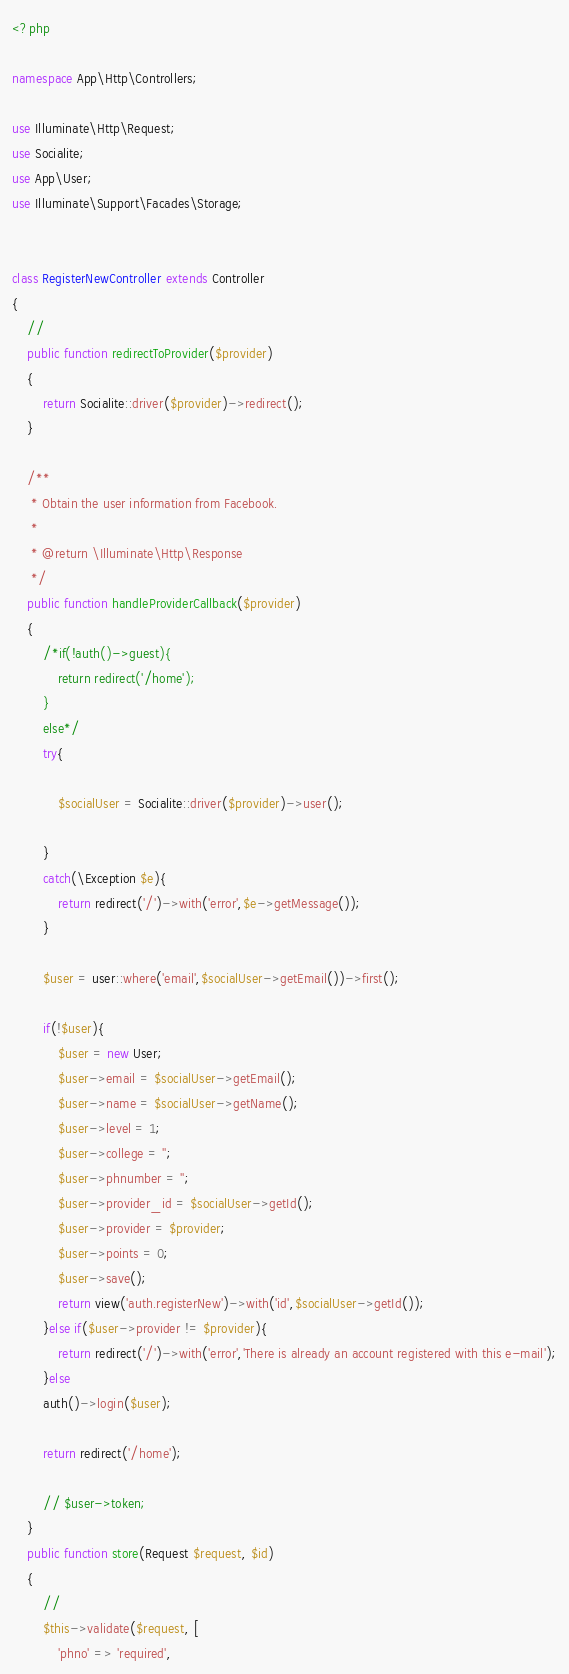Convert code to text. <code><loc_0><loc_0><loc_500><loc_500><_PHP_><?php

namespace App\Http\Controllers;

use Illuminate\Http\Request;
use Socialite;
use App\User;
use Illuminate\Support\Facades\Storage;


class RegisterNewController extends Controller
{
    //
    public function redirectToProvider($provider)
    {
        return Socialite::driver($provider)->redirect();
    }

    /**
     * Obtain the user information from Facebook.
     *
     * @return \Illuminate\Http\Response
     */
    public function handleProviderCallback($provider)
    {   
        /*if(!auth()->guest){
            return redirect('/home');
        }
        else*/
        try{

            $socialUser = Socialite::driver($provider)->user();

        }
        catch(\Exception $e){
            return redirect('/')->with('error',$e->getMessage());
        }

        $user = user::where('email',$socialUser->getEmail())->first();

        if(!$user){
            $user = new User;
            $user->email = $socialUser->getEmail();
            $user->name = $socialUser->getName();
            $user->level = 1;
            $user->college = '';
            $user->phnumber = '';
            $user->provider_id = $socialUser->getId();
            $user->provider = $provider;
            $user->points = 0;
            $user->save();
            return view('auth.registerNew')->with('id',$socialUser->getId());
        }else if($user->provider != $provider){
            return redirect('/')->with('error','There is already an account registered with this e-mail');
        }else
        auth()->login($user);

        return redirect('/home');
        
        // $user->token;
    }
    public function store(Request $request, $id)
    {
        //
        $this->validate($request, [
            'phno' => 'required',</code> 